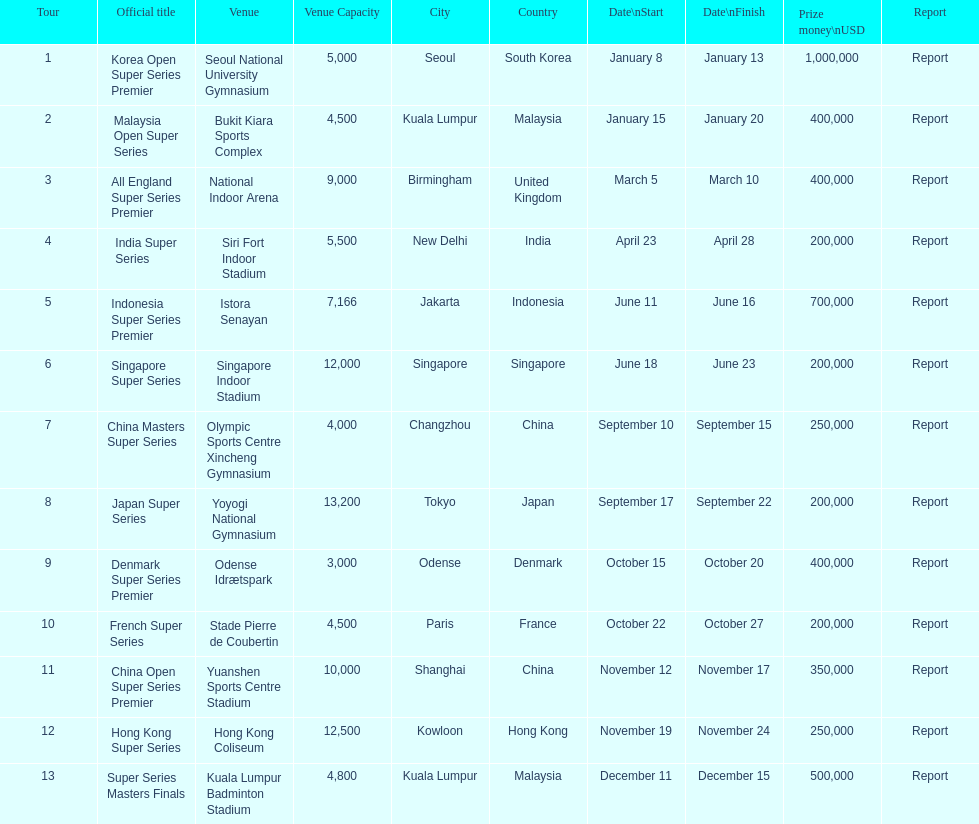How long did the japan super series take? 5 days. 